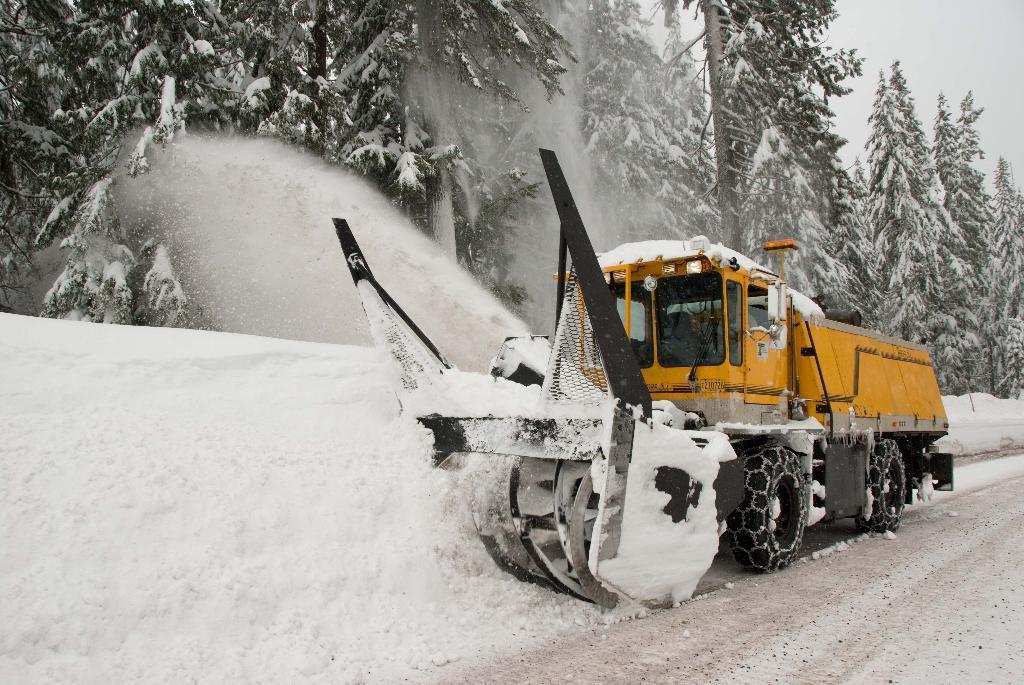Describe this image in one or two sentences. This image is taken outdoors. At the bottom of the image there is a ground covered with snow. In the background there are many trees covered with snow. At the top of the image there is a sky. In the middle of the image a vehicle is moving on the ground to remove the snow which is on the ground. 